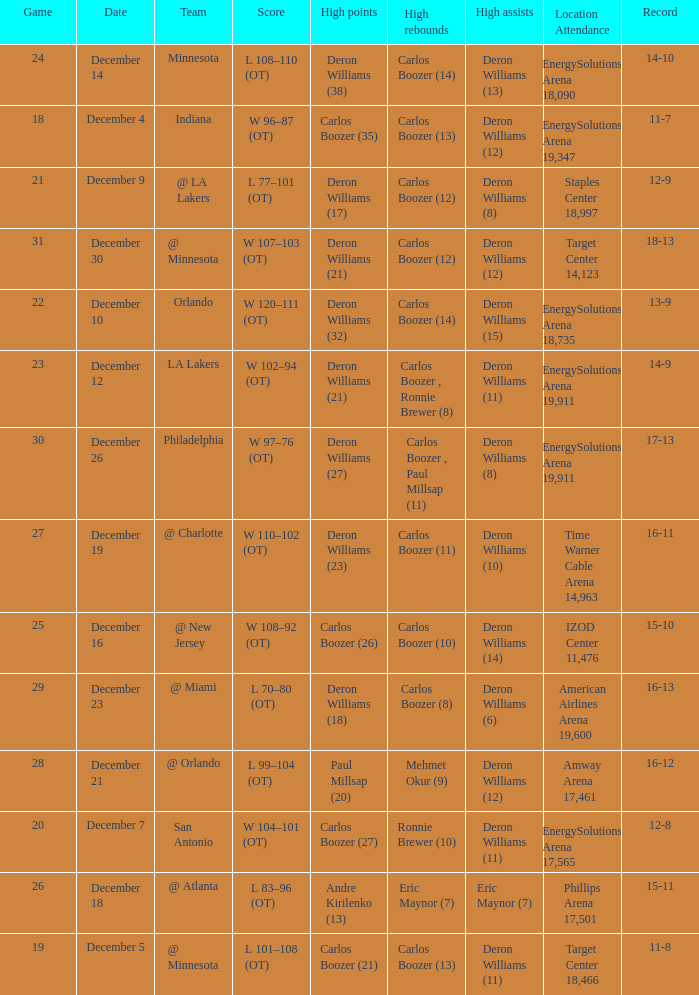How many different high rebound results are there for the game number 26? 1.0. 